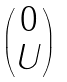Convert formula to latex. <formula><loc_0><loc_0><loc_500><loc_500>\begin{pmatrix} 0 \\ U \end{pmatrix}</formula> 